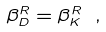Convert formula to latex. <formula><loc_0><loc_0><loc_500><loc_500>\beta ^ { R } _ { D } = \beta ^ { R } _ { K } \ ,</formula> 